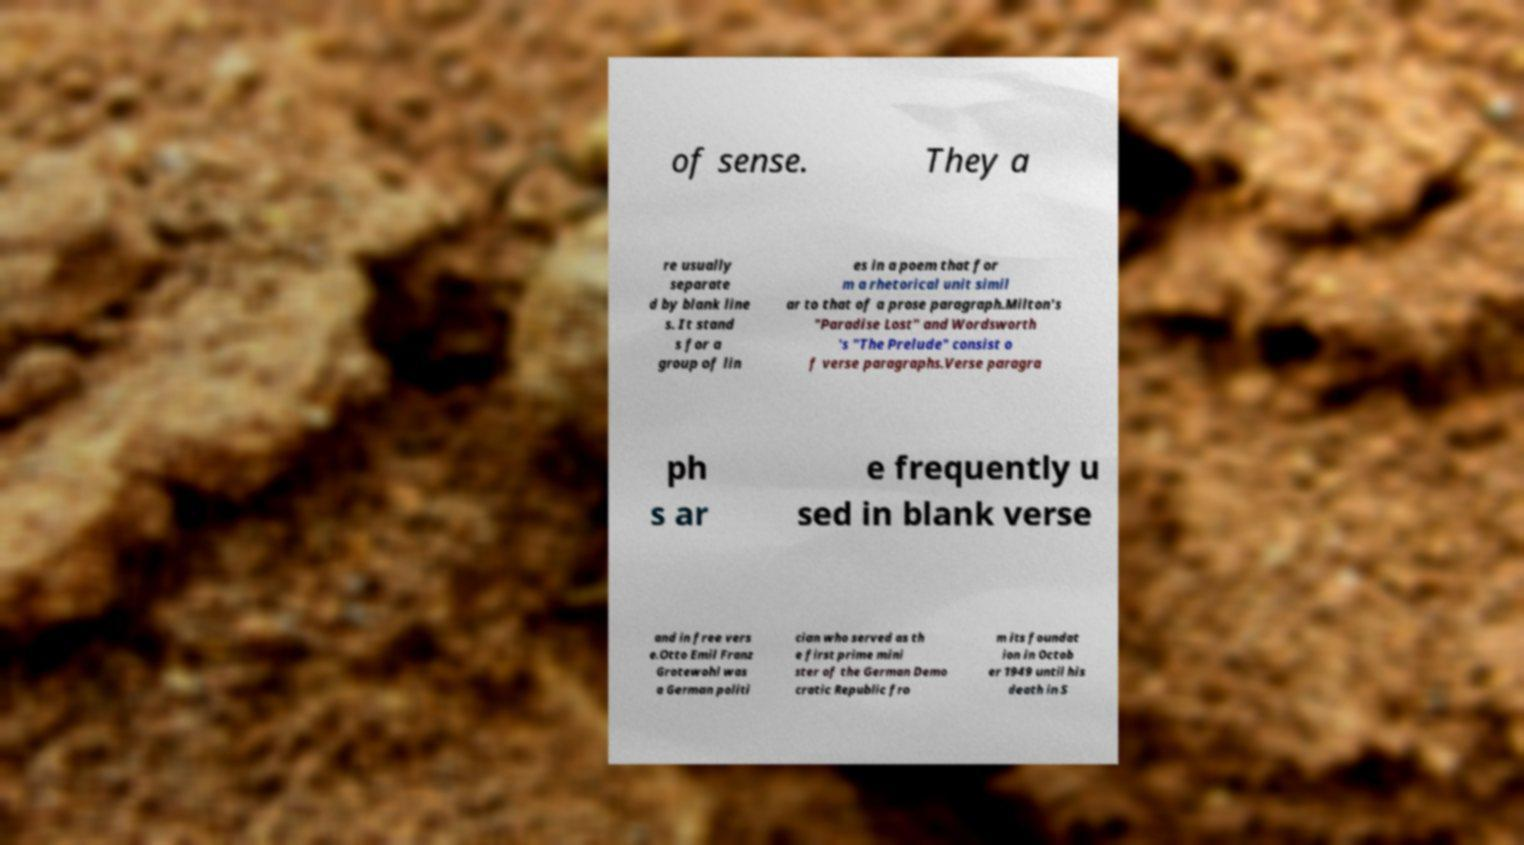I need the written content from this picture converted into text. Can you do that? of sense. They a re usually separate d by blank line s. It stand s for a group of lin es in a poem that for m a rhetorical unit simil ar to that of a prose paragraph.Milton's "Paradise Lost" and Wordsworth 's "The Prelude" consist o f verse paragraphs.Verse paragra ph s ar e frequently u sed in blank verse and in free vers e.Otto Emil Franz Grotewohl was a German politi cian who served as th e first prime mini ster of the German Demo cratic Republic fro m its foundat ion in Octob er 1949 until his death in S 